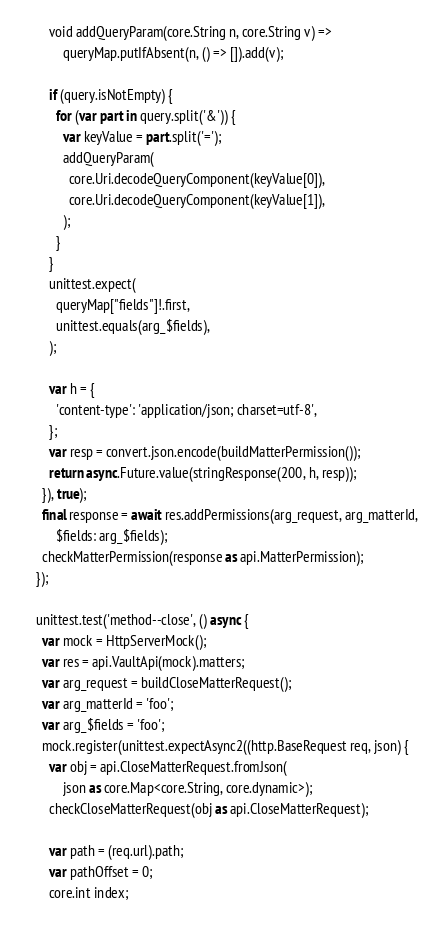<code> <loc_0><loc_0><loc_500><loc_500><_Dart_>        void addQueryParam(core.String n, core.String v) =>
            queryMap.putIfAbsent(n, () => []).add(v);

        if (query.isNotEmpty) {
          for (var part in query.split('&')) {
            var keyValue = part.split('=');
            addQueryParam(
              core.Uri.decodeQueryComponent(keyValue[0]),
              core.Uri.decodeQueryComponent(keyValue[1]),
            );
          }
        }
        unittest.expect(
          queryMap["fields"]!.first,
          unittest.equals(arg_$fields),
        );

        var h = {
          'content-type': 'application/json; charset=utf-8',
        };
        var resp = convert.json.encode(buildMatterPermission());
        return async.Future.value(stringResponse(200, h, resp));
      }), true);
      final response = await res.addPermissions(arg_request, arg_matterId,
          $fields: arg_$fields);
      checkMatterPermission(response as api.MatterPermission);
    });

    unittest.test('method--close', () async {
      var mock = HttpServerMock();
      var res = api.VaultApi(mock).matters;
      var arg_request = buildCloseMatterRequest();
      var arg_matterId = 'foo';
      var arg_$fields = 'foo';
      mock.register(unittest.expectAsync2((http.BaseRequest req, json) {
        var obj = api.CloseMatterRequest.fromJson(
            json as core.Map<core.String, core.dynamic>);
        checkCloseMatterRequest(obj as api.CloseMatterRequest);

        var path = (req.url).path;
        var pathOffset = 0;
        core.int index;</code> 